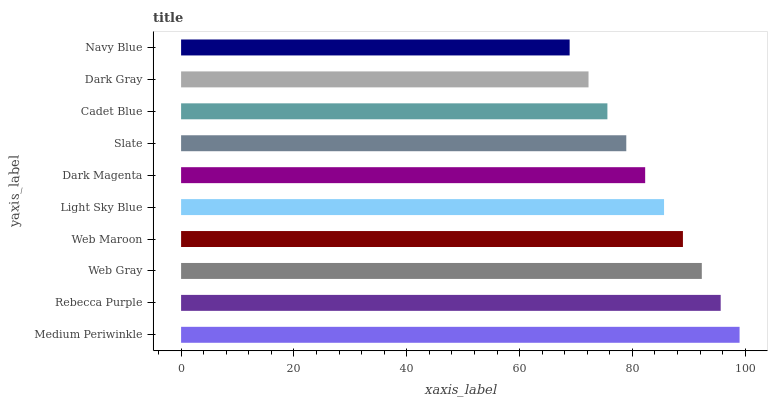Is Navy Blue the minimum?
Answer yes or no. Yes. Is Medium Periwinkle the maximum?
Answer yes or no. Yes. Is Rebecca Purple the minimum?
Answer yes or no. No. Is Rebecca Purple the maximum?
Answer yes or no. No. Is Medium Periwinkle greater than Rebecca Purple?
Answer yes or no. Yes. Is Rebecca Purple less than Medium Periwinkle?
Answer yes or no. Yes. Is Rebecca Purple greater than Medium Periwinkle?
Answer yes or no. No. Is Medium Periwinkle less than Rebecca Purple?
Answer yes or no. No. Is Light Sky Blue the high median?
Answer yes or no. Yes. Is Dark Magenta the low median?
Answer yes or no. Yes. Is Cadet Blue the high median?
Answer yes or no. No. Is Navy Blue the low median?
Answer yes or no. No. 